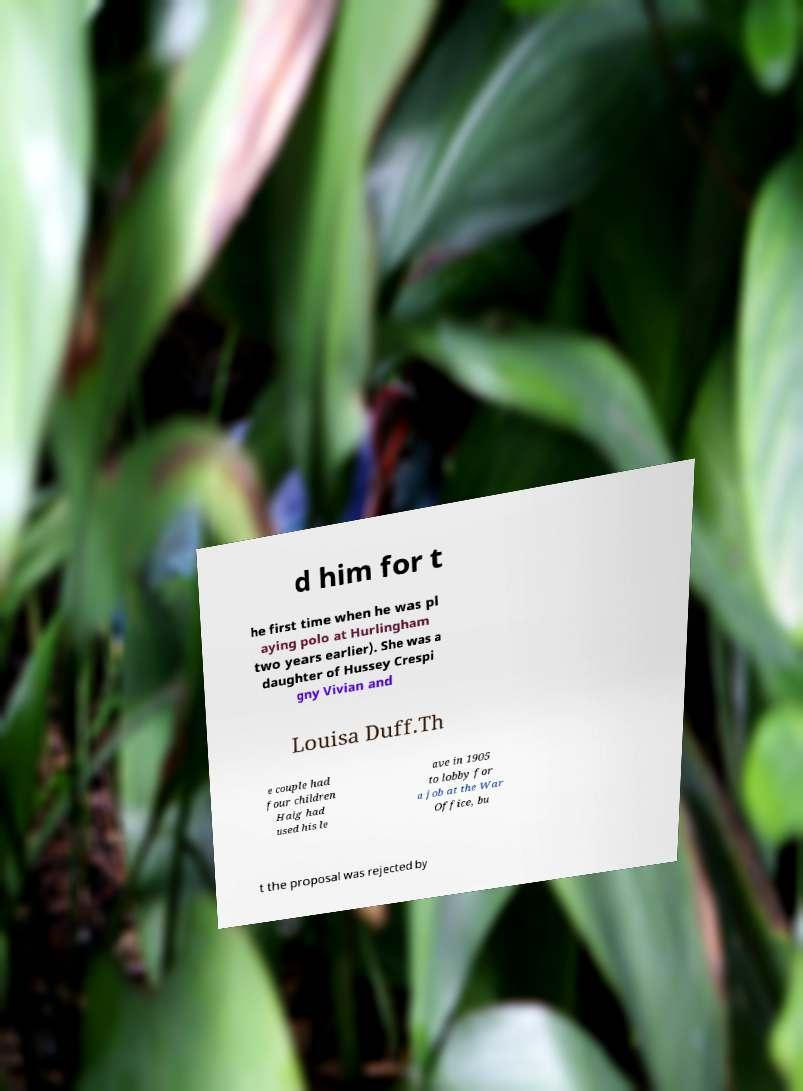What messages or text are displayed in this image? I need them in a readable, typed format. d him for t he first time when he was pl aying polo at Hurlingham two years earlier). She was a daughter of Hussey Crespi gny Vivian and Louisa Duff.Th e couple had four children Haig had used his le ave in 1905 to lobby for a job at the War Office, bu t the proposal was rejected by 